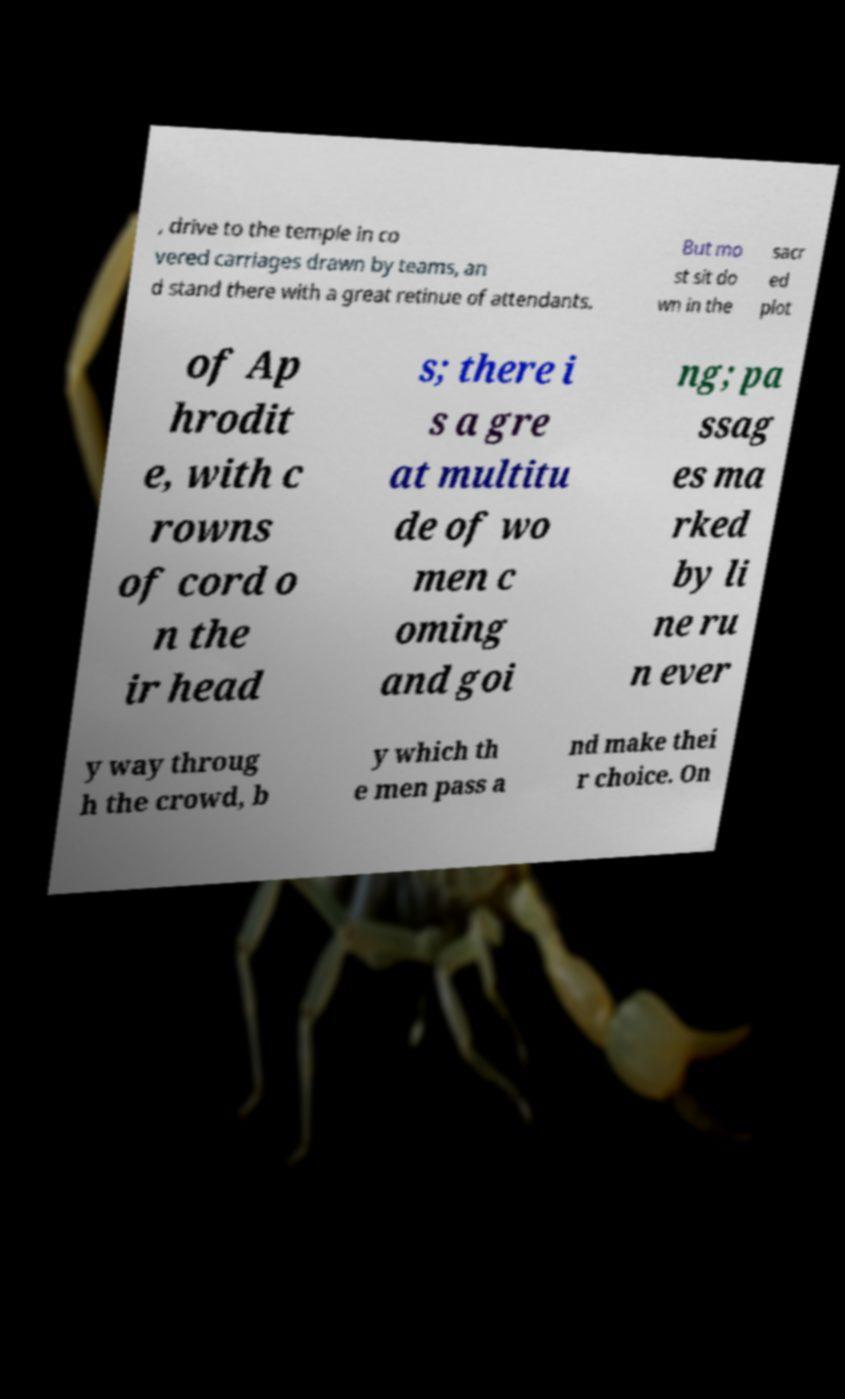For documentation purposes, I need the text within this image transcribed. Could you provide that? , drive to the temple in co vered carriages drawn by teams, an d stand there with a great retinue of attendants. But mo st sit do wn in the sacr ed plot of Ap hrodit e, with c rowns of cord o n the ir head s; there i s a gre at multitu de of wo men c oming and goi ng; pa ssag es ma rked by li ne ru n ever y way throug h the crowd, b y which th e men pass a nd make thei r choice. On 